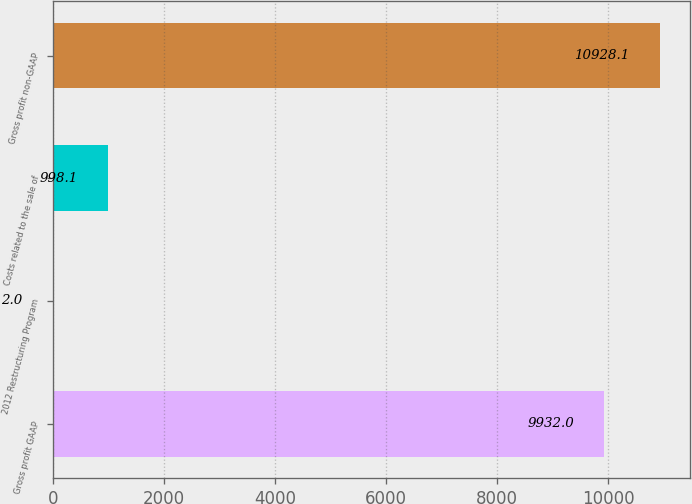Convert chart to OTSL. <chart><loc_0><loc_0><loc_500><loc_500><bar_chart><fcel>Gross profit GAAP<fcel>2012 Restructuring Program<fcel>Costs related to the sale of<fcel>Gross profit non-GAAP<nl><fcel>9932<fcel>2<fcel>998.1<fcel>10928.1<nl></chart> 